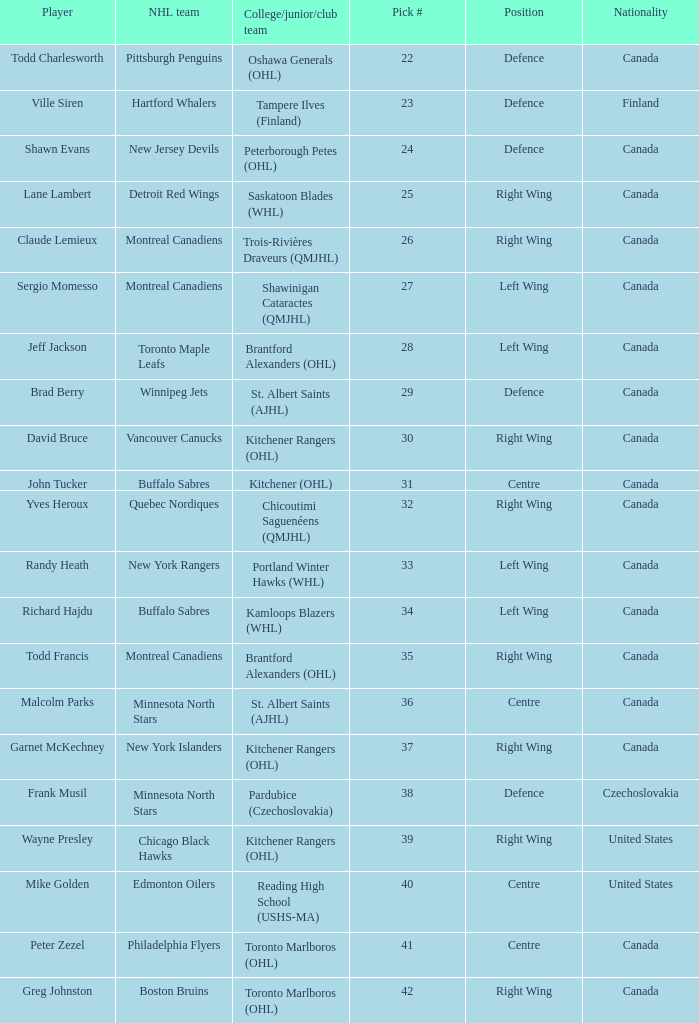What is the position for the nhl team toronto maple leafs? Left Wing. 